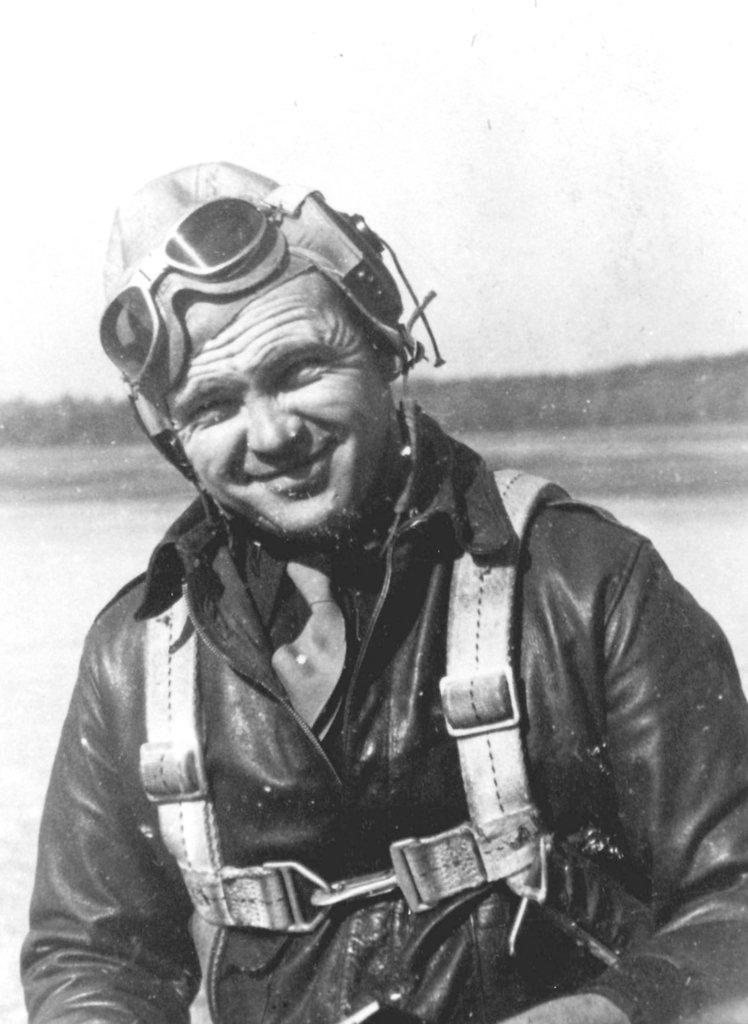Who is present in the image? There is a man in the image. What is the man wearing? The man is wearing a black coat. What can be seen behind the man? There is water visible behind the man. Who is the owner of the cherry in the image? There is no cherry present in the image, so it is not possible to determine the owner. 